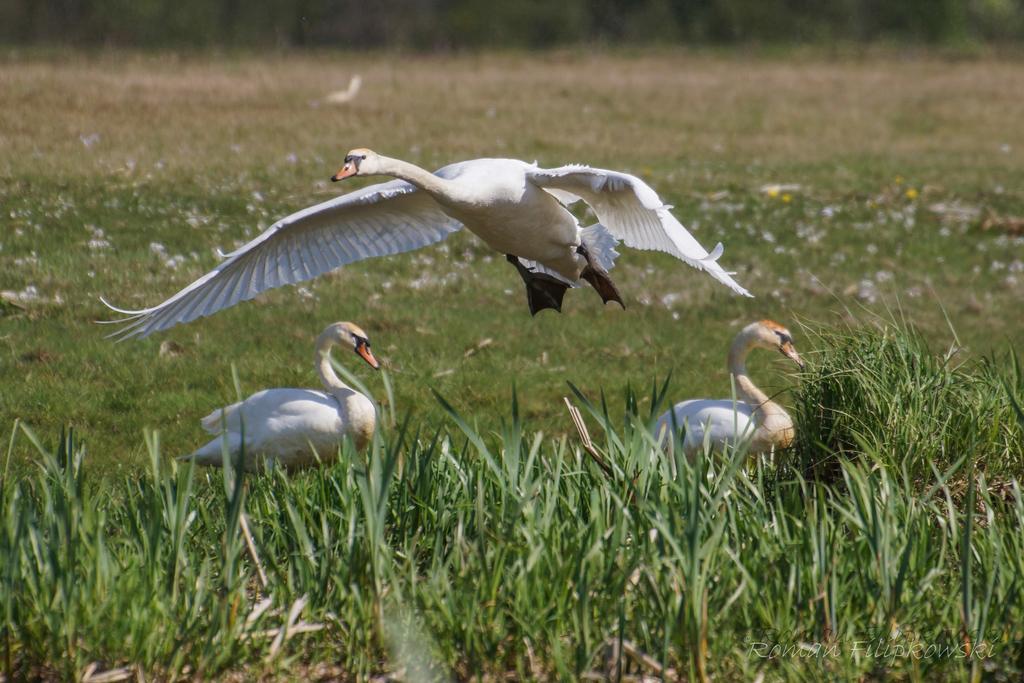Describe this image in one or two sentences. In this picture we can see three birds,two birds are on the ground and one bird is flying. 